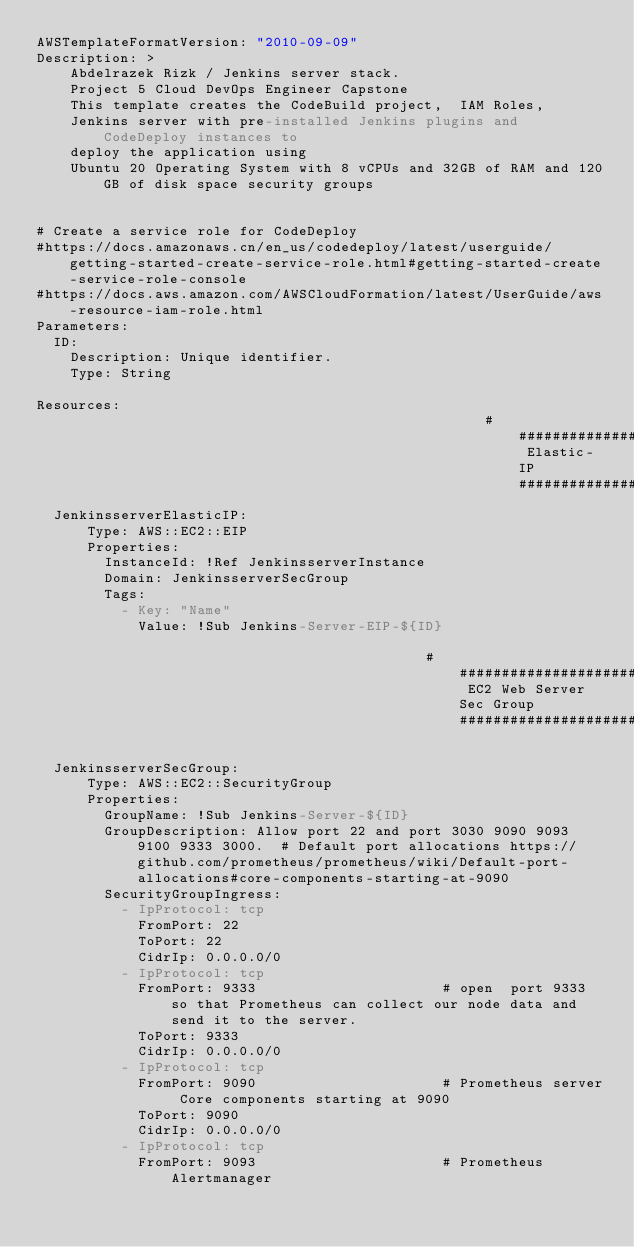Convert code to text. <code><loc_0><loc_0><loc_500><loc_500><_YAML_>AWSTemplateFormatVersion: "2010-09-09"
Description: >
    Abdelrazek Rizk / Jenkins server stack.
    Project 5 Cloud DevOps Engineer Capstone
    This template creates the CodeBuild project,  IAM Roles,
    Jenkins server with pre-installed Jenkins plugins and CodeDeploy instances to
    deploy the application using
    Ubuntu 20 Operating System with 8 vCPUs and 32GB of RAM and 120GB of disk space security groups
     

# Create a service role for CodeDeploy
#https://docs.amazonaws.cn/en_us/codedeploy/latest/userguide/getting-started-create-service-role.html#getting-started-create-service-role-console
#https://docs.aws.amazon.com/AWSCloudFormation/latest/UserGuide/aws-resource-iam-role.html
Parameters:
  ID:
    Description: Unique identifier.
    Type: String

Resources:
                                                     ################################### Elastic-IP ####################################
  JenkinsserverElasticIP:
      Type: AWS::EC2::EIP
      Properties:
        InstanceId: !Ref JenkinsserverInstance
        Domain: JenkinsserverSecGroup
        Tags:
          - Key: "Name"
            Value: !Sub Jenkins-Server-EIP-${ID}

                                              ################################### EC2 Web Server Sec Group ####################################

  JenkinsserverSecGroup:
      Type: AWS::EC2::SecurityGroup
      Properties:
        GroupName: !Sub Jenkins-Server-${ID}
        GroupDescription: Allow port 22 and port 3030 9090 9093 9100 9333 3000.  # Default port allocations https://github.com/prometheus/prometheus/wiki/Default-port-allocations#core-components-starting-at-9090
        SecurityGroupIngress:
          - IpProtocol: tcp
            FromPort: 22
            ToPort: 22
            CidrIp: 0.0.0.0/0
          - IpProtocol: tcp
            FromPort: 9333                      # open  port 9333 so that Prometheus can collect our node data and send it to the server.
            ToPort: 9333
            CidrIp: 0.0.0.0/0        
          - IpProtocol: tcp  
            FromPort: 9090                      # Prometheus server Core components starting at 9090
            ToPort: 9090
            CidrIp: 0.0.0.0/0
          - IpProtocol: tcp
            FromPort: 9093                      # Prometheus Alertmanager</code> 